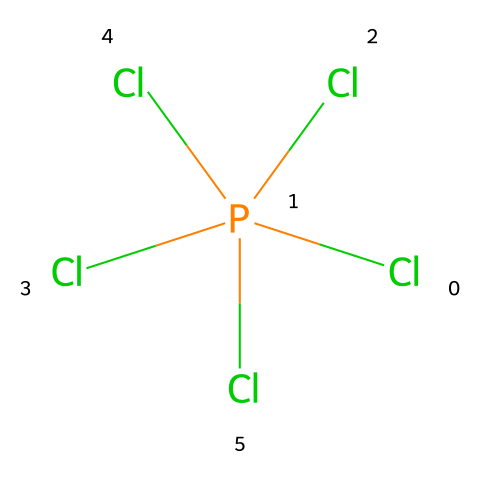What is the molecular formula of this compound? The SMILES representation shows one phosphorus atom (P) and five chlorine atoms (Cl). Therefore, the molecular formula can be derived as PCl5.
Answer: PCl5 How many chlorine atoms are present in this structure? By examining the SMILES, we see that there are five instances of "Cl", indicating five chlorine atoms.
Answer: five What type of compound is phosphorus pentachloride classified as? Phosphorus pentachloride contains a phosphorus atom with more than four bonds (it has five in total with chlorine), characterizing it as a hypervalent compound.
Answer: hypervalent What is the oxidation state of phosphorus in this compound? In PCl5, phosphorus typically has an oxidation state of +5, as it donates five electrons to form bonds with chlorine atoms.
Answer: +5 How many bonds does phosphorus form in this structure? The structure indicates phosphorus is bonded to five chlorine atoms, which shows that phosphorus forms five covalent bonds.
Answer: five What role does phosphorus pentachloride play in the context of textiles? Phosphorus pentachloride is used in the manufacture of flame retardants, contributing to the safety of fashionable textiles by reducing flammability.
Answer: flame retardants 